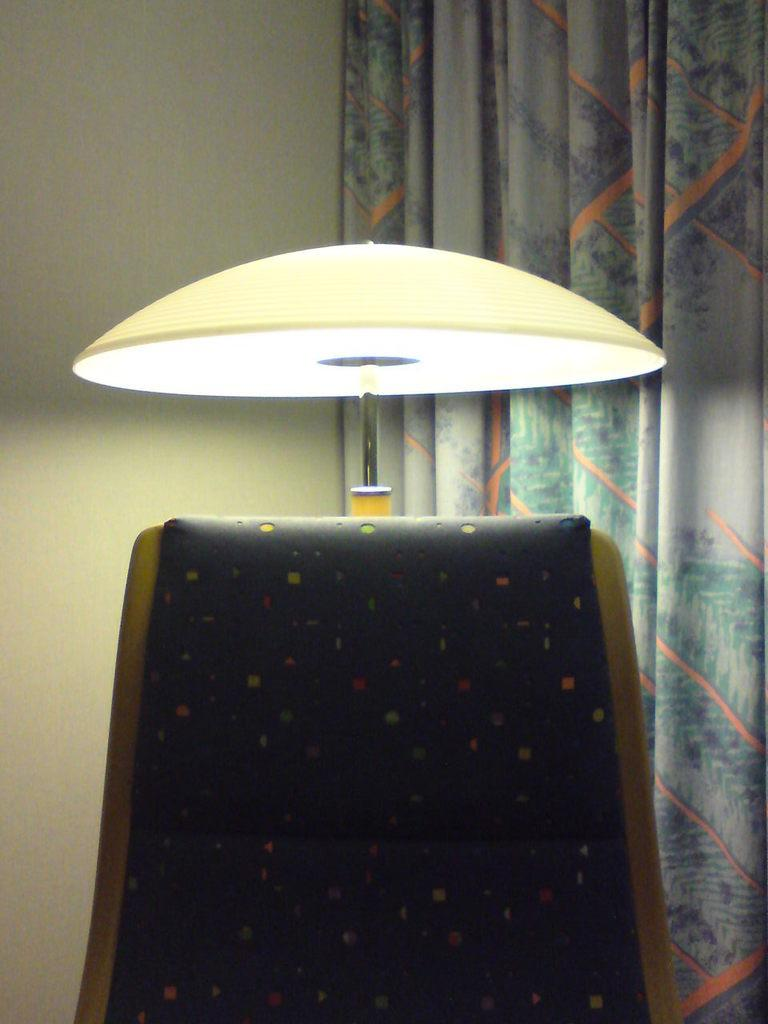What is located in the middle of the image? There is a lamp in the middle of the image. What can be seen on the right side of the image? There is a curtain on the right side of the image. What is on the left side of the image? There is a wall on the left side of the image. How many pigs are visible in the image? There are no pigs present in the image; it features a lamp, a curtain, and a wall. What type of cattle can be seen grazing near the wall in the image? There is no cattle present in the image; it only features a lamp, a curtain, and a wall. 